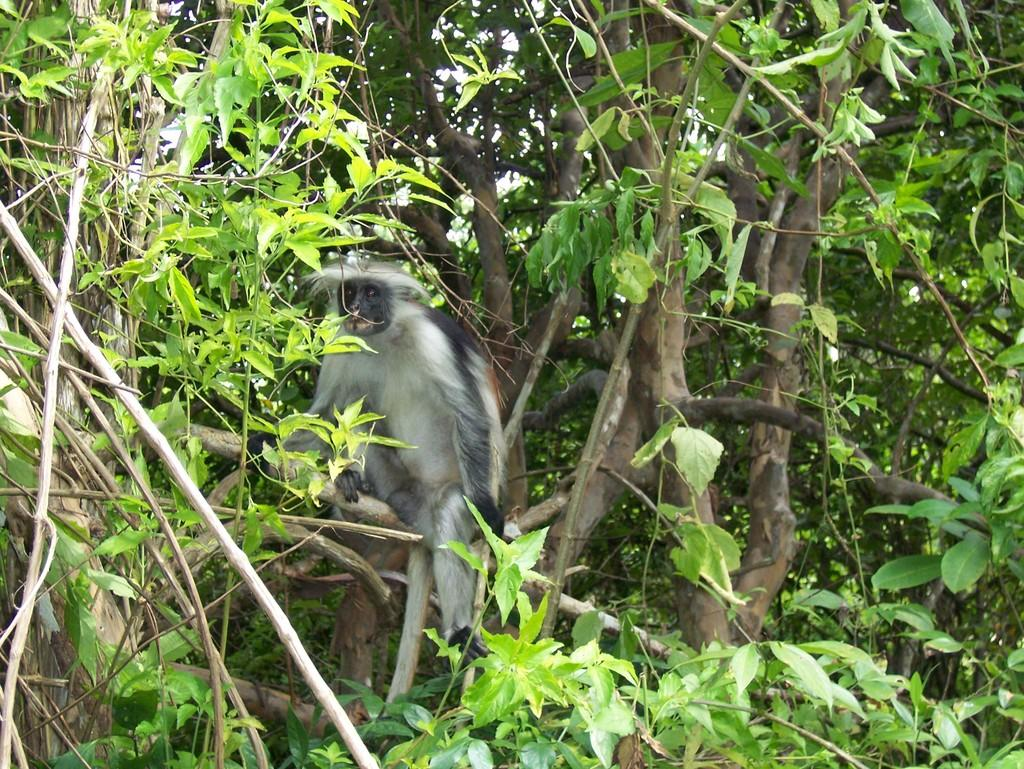What animal is present in the image? There is a monkey in the image. Where is the monkey located? The monkey is sitting on a tree. What can be seen in the background of the tree? The tree has leaves and stems in the background. What type of noise can be heard coming from the fairies in the image? There are no fairies present in the image, so it is not possible to determine what, if any, noise they might be making. 